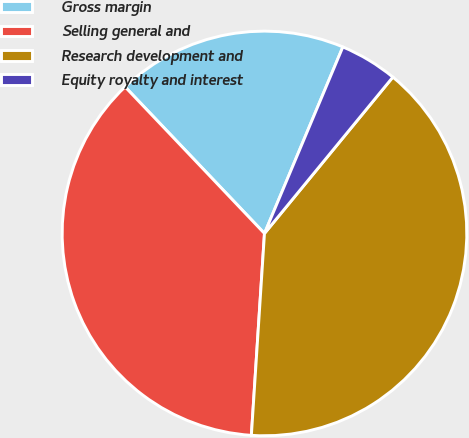<chart> <loc_0><loc_0><loc_500><loc_500><pie_chart><fcel>Gross margin<fcel>Selling general and<fcel>Research development and<fcel>Equity royalty and interest<nl><fcel>18.43%<fcel>36.87%<fcel>40.09%<fcel>4.61%<nl></chart> 